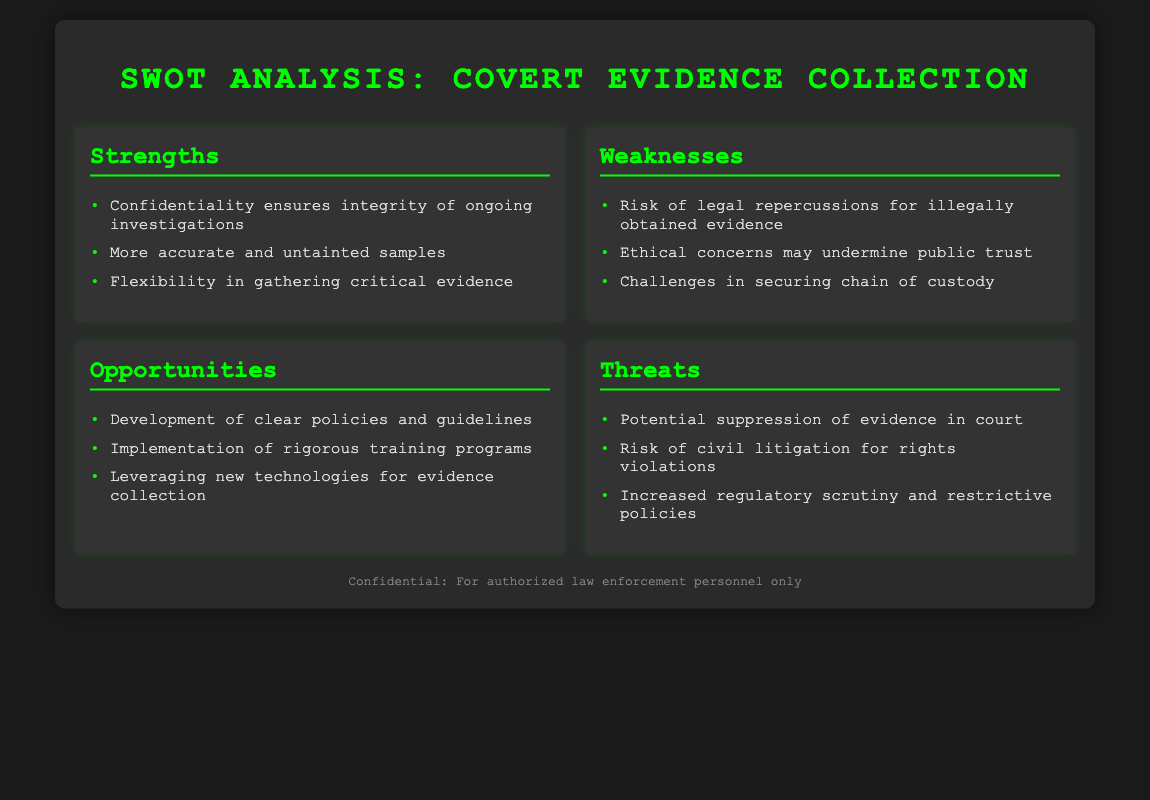what is the title of the document? The title of the document is displayed prominently at the top, stating the focus of the analysis.
Answer: SWOT Analysis: Covert Evidence Collection how many strengths are listed? The number of strengths can be counted from the section detailing strengths.
Answer: three name one ethical concern mentioned in the weaknesses section. The weaknesses section identifies several ethical issues, highlighting concerns regarding public trust.
Answer: public trust what is one opportunity for reform highlighted in the document? The opportunities section provides various points for potential reform; one specific opportunity can be listed.
Answer: Development of clear policies and guidelines what threat involves legal repercussions? The threats section outlines potential legal issues, one of which pertains to legal repercussions for police actions.
Answer: civil litigation for rights violations which section addresses the flexibility in gathering evidence? The strengths section specifically discusses flexibility as a positive aspect of covert evidence collection.
Answer: Strengths how many threats are identified in the document? The number of threats can be counted from the section discussing threats.
Answer: three what is one technological opportunity mentioned? The opportunities section hints at the incorporation of new technologies for enhanced evidence collection.
Answer: Leveraging new technologies for evidence collection 